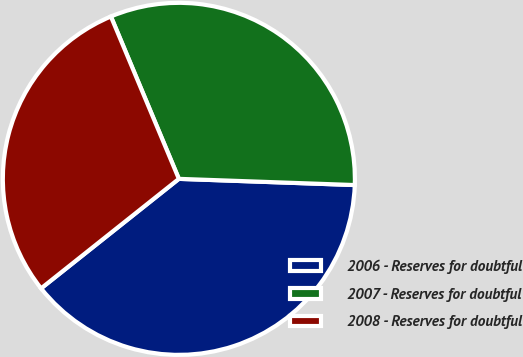Convert chart. <chart><loc_0><loc_0><loc_500><loc_500><pie_chart><fcel>2006 - Reserves for doubtful<fcel>2007 - Reserves for doubtful<fcel>2008 - Reserves for doubtful<nl><fcel>38.75%<fcel>31.87%<fcel>29.38%<nl></chart> 